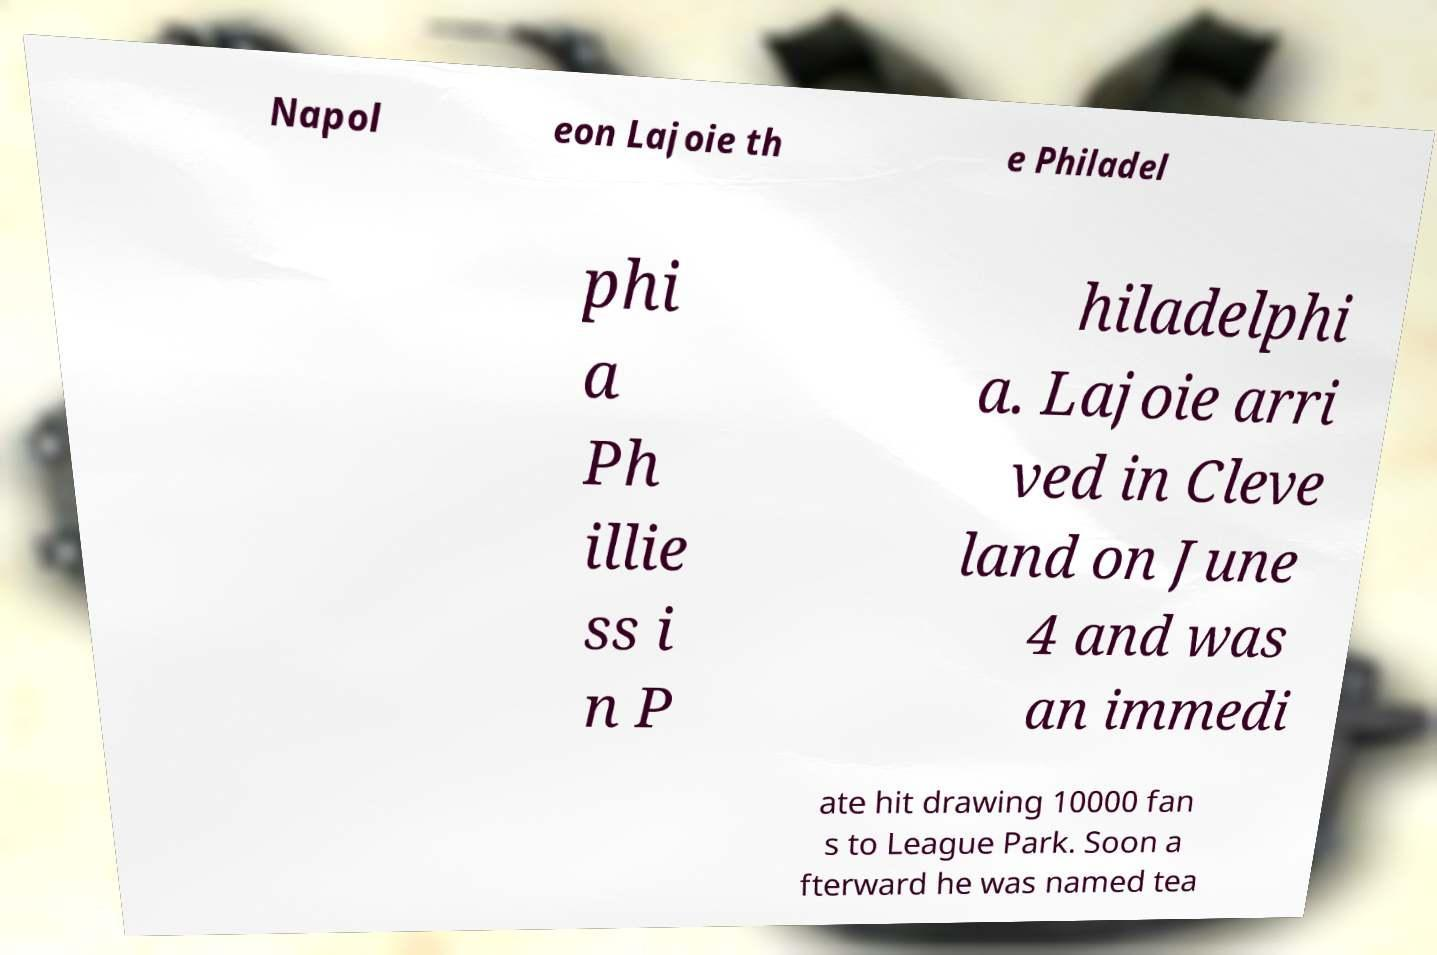What messages or text are displayed in this image? I need them in a readable, typed format. Napol eon Lajoie th e Philadel phi a Ph illie ss i n P hiladelphi a. Lajoie arri ved in Cleve land on June 4 and was an immedi ate hit drawing 10000 fan s to League Park. Soon a fterward he was named tea 